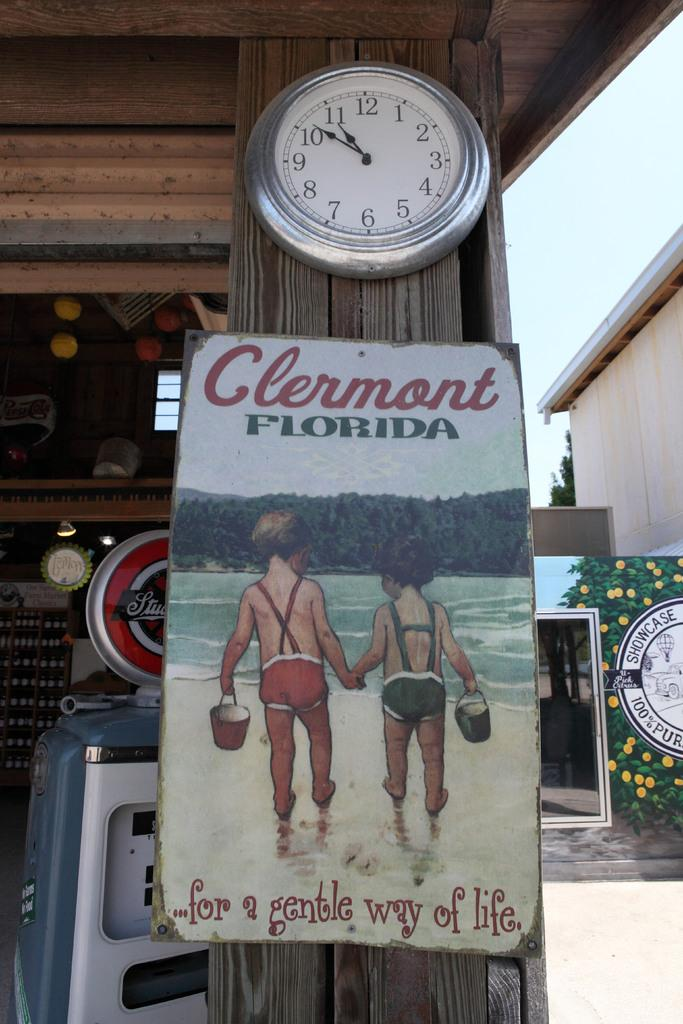<image>
Offer a succinct explanation of the picture presented. A sign with two boys holding hands that says Clermont Florida 